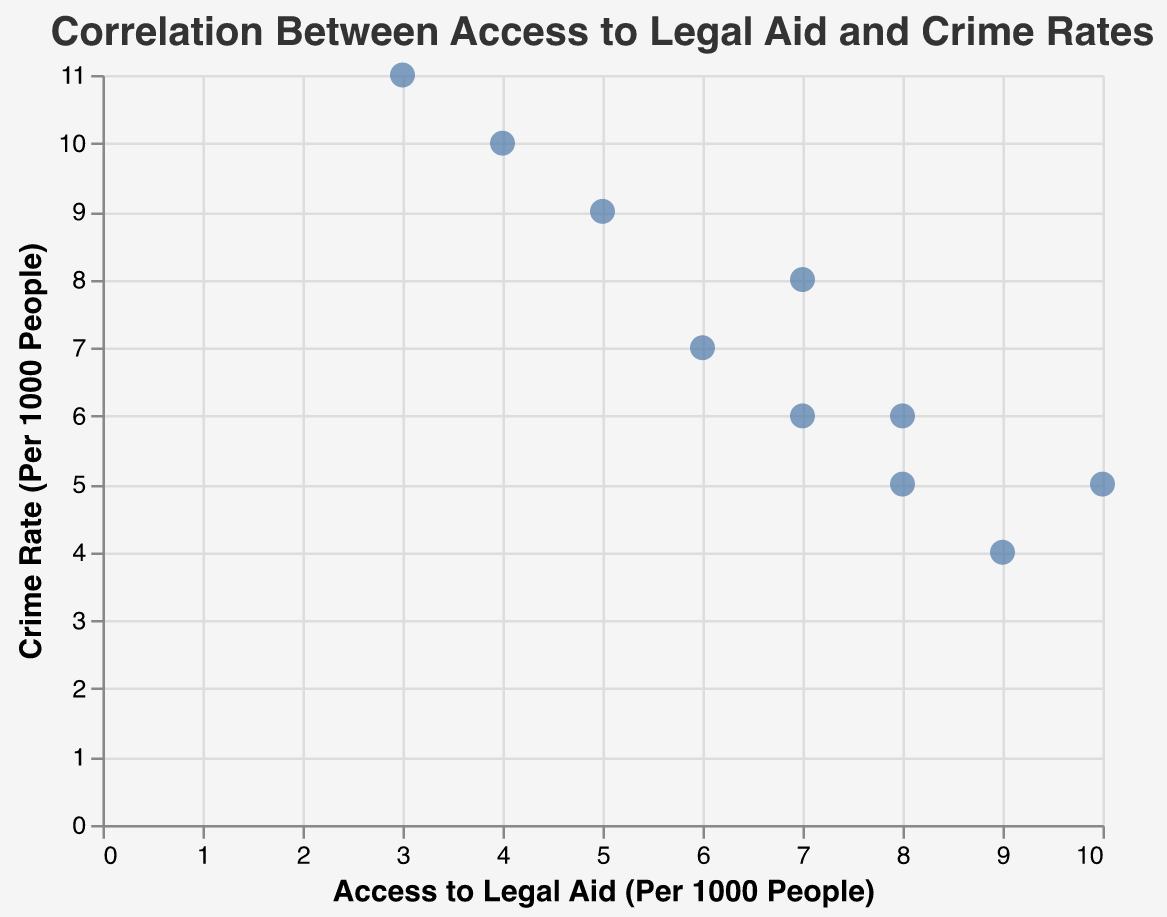What is the title of the plot? The plot's title is typically displayed at the top of the figure. By reading the title, we can understand the main subject of the plot.
Answer: Correlation Between Access to Legal Aid and Crime Rates How many data points are there in the plot? In scatter plots, each data point represents an individual entry. By counting these, we can determine the total number of observations displayed.
Answer: 10 Which region has the highest access to legal aid? We need to look at the x-axis, which represents Access to Legal Aid (Per 1000 People), and find the point farthest to the right. The tooltip can help identify the region.
Answer: New York Which region has the highest crime rate? By examining the y-axis, which represents Crime Rate (Per 1000 People), we locate the point highest on the axis. The tooltip provides the region's name.
Answer: Georgia What is the relationship between access to legal aid and crime rates as observed in the scatter plot? We need to determine the overall trend suggested by the scatter plot points. By inspecting their layout, we see if there's a positive or negative correlation or no clear pattern.
Answer: Generally inverse Compare the crime rate of Florida and Ohio. Which is higher? Identify the data points for each region using the tooltips, and then compare their y-values (Crime Rate per 1000 People).
Answer: Florida What is the average access to legal aid across all regions? Sum the Access to Legal Aid values for all regions and divide by the number of regions (10). (10 + 7 + 6 + 4 + 8 + 9 + 5 + 3 + 7 + 8) / 10 = 67 / 10 = 6.7
Answer: 6.7 Does Michigan have a lower crime rate compared to Illinois? Locate each region's data point and compare their y-values (Crime Rate per 1000 People) to determine which region has a lower crime rate.
Answer: Yes Calculate the difference in crime rate between the regions with the highest and lowest access to legal aid. Find the data points for the regions with the highest (New York, 5) and lowest (Georgia, 11) access to legal aid, and then subtract the lower crime rate from the higher one: 11 - 5 = 6
Answer: 6 Is there an overall trend suggesting that increased access to legal aid correlates with lower crime rates? By examining the scatter plot, observe whether points with higher access to legal aid tend to be aligned with lower crime rates, indicating a possible inverse relationship.
Answer: Yes 